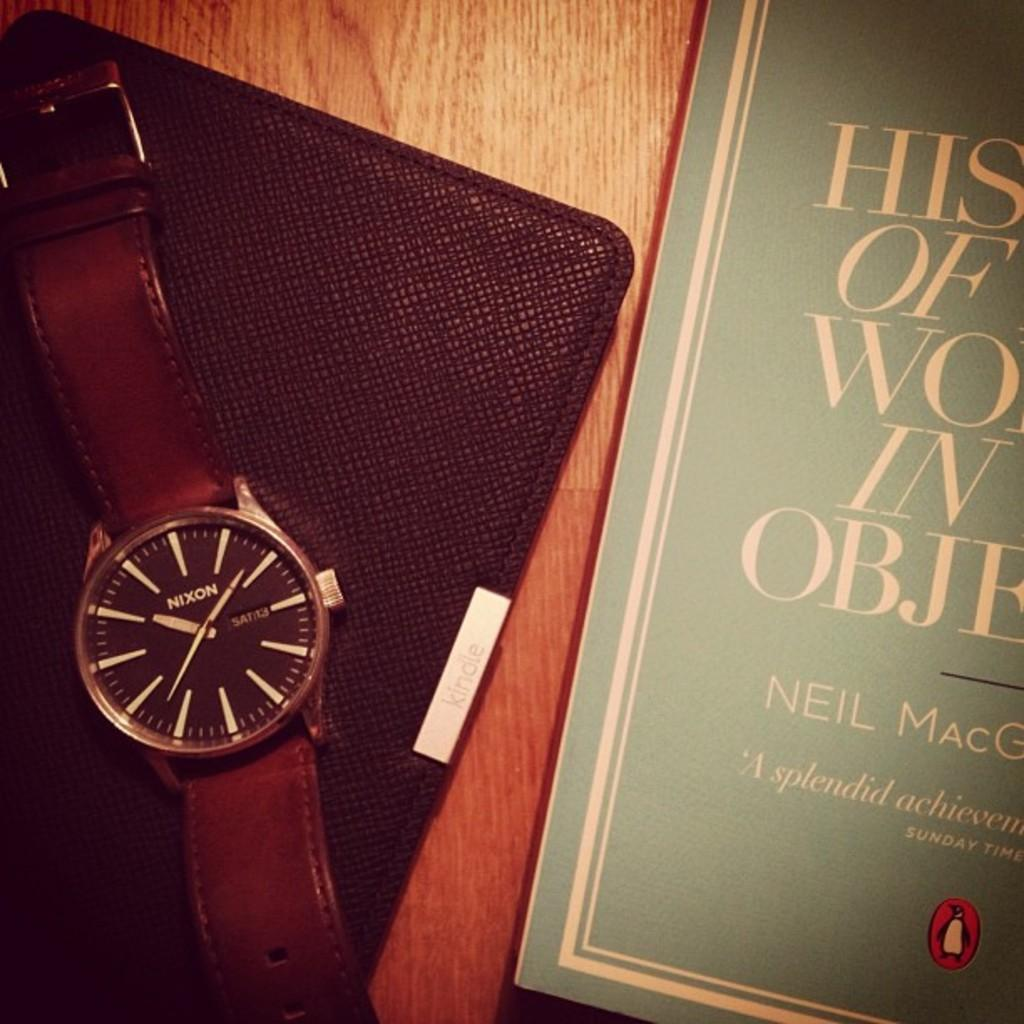<image>
Write a terse but informative summary of the picture. the face of a Nixon branded wrist watch whos time reads 10:39 and is sitting next to a book. 